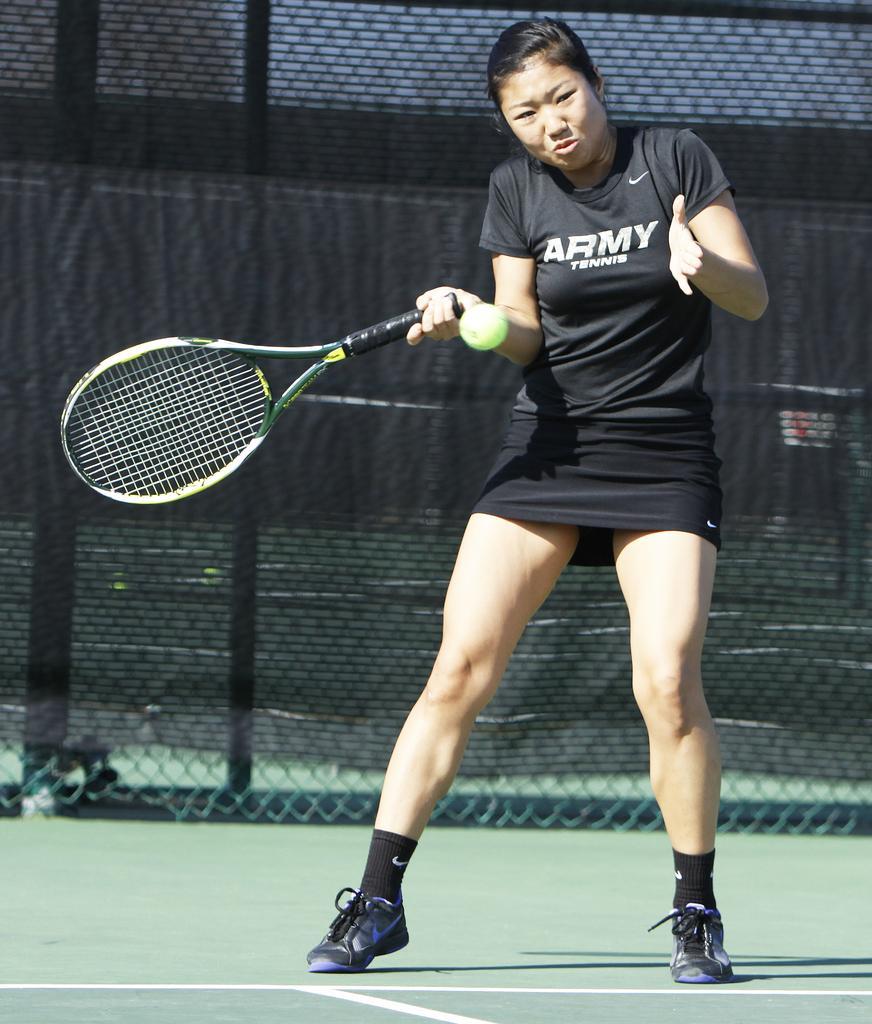In one or two sentences, can you explain what this image depicts? On the background we can see a net in black colour. We can see a woman holding a tennis racket in her hand. This is a ball and this is a playground. 